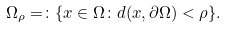Convert formula to latex. <formula><loc_0><loc_0><loc_500><loc_500>\Omega _ { \rho } = \colon \{ x \in \Omega \colon d ( x , \partial \Omega ) < \rho \} .</formula> 